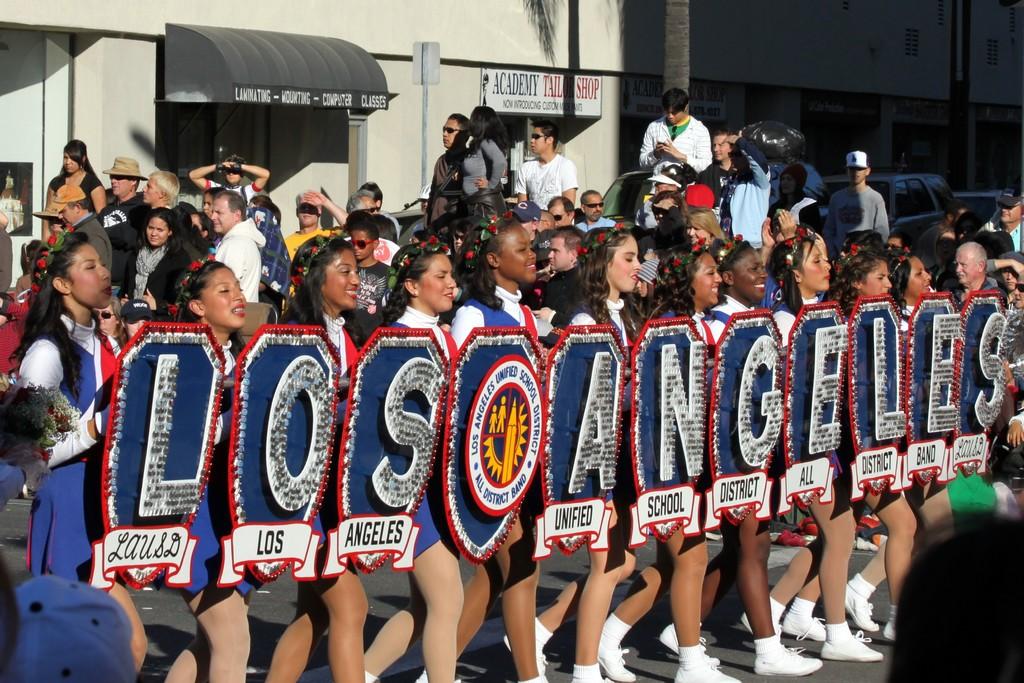What town name are the girls spelling out?
Your answer should be very brief. Los angeles. What is the full name of the school district these women represent?
Keep it short and to the point. Los angeles unified school district. 